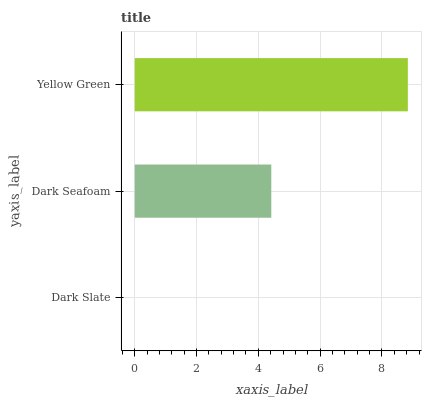Is Dark Slate the minimum?
Answer yes or no. Yes. Is Yellow Green the maximum?
Answer yes or no. Yes. Is Dark Seafoam the minimum?
Answer yes or no. No. Is Dark Seafoam the maximum?
Answer yes or no. No. Is Dark Seafoam greater than Dark Slate?
Answer yes or no. Yes. Is Dark Slate less than Dark Seafoam?
Answer yes or no. Yes. Is Dark Slate greater than Dark Seafoam?
Answer yes or no. No. Is Dark Seafoam less than Dark Slate?
Answer yes or no. No. Is Dark Seafoam the high median?
Answer yes or no. Yes. Is Dark Seafoam the low median?
Answer yes or no. Yes. Is Dark Slate the high median?
Answer yes or no. No. Is Yellow Green the low median?
Answer yes or no. No. 